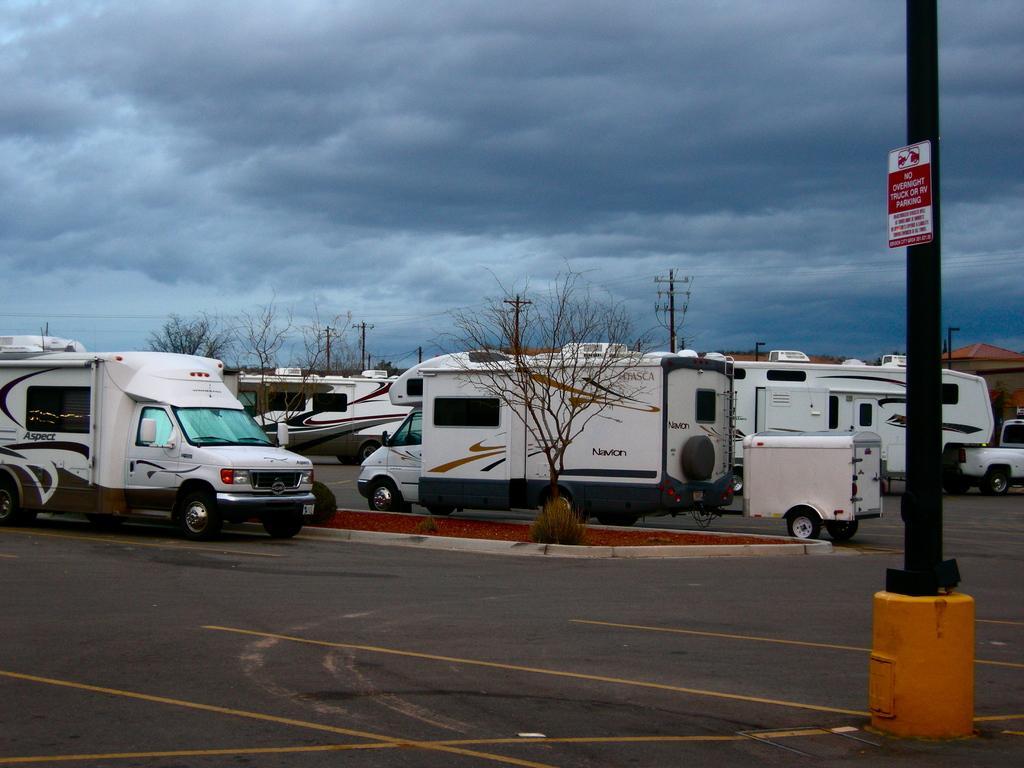Can you describe this image briefly? In this image there are vans on the road. There are electric poles. There are trees. At the top of the image there are clouds. There is a pole to the right side of the image. 